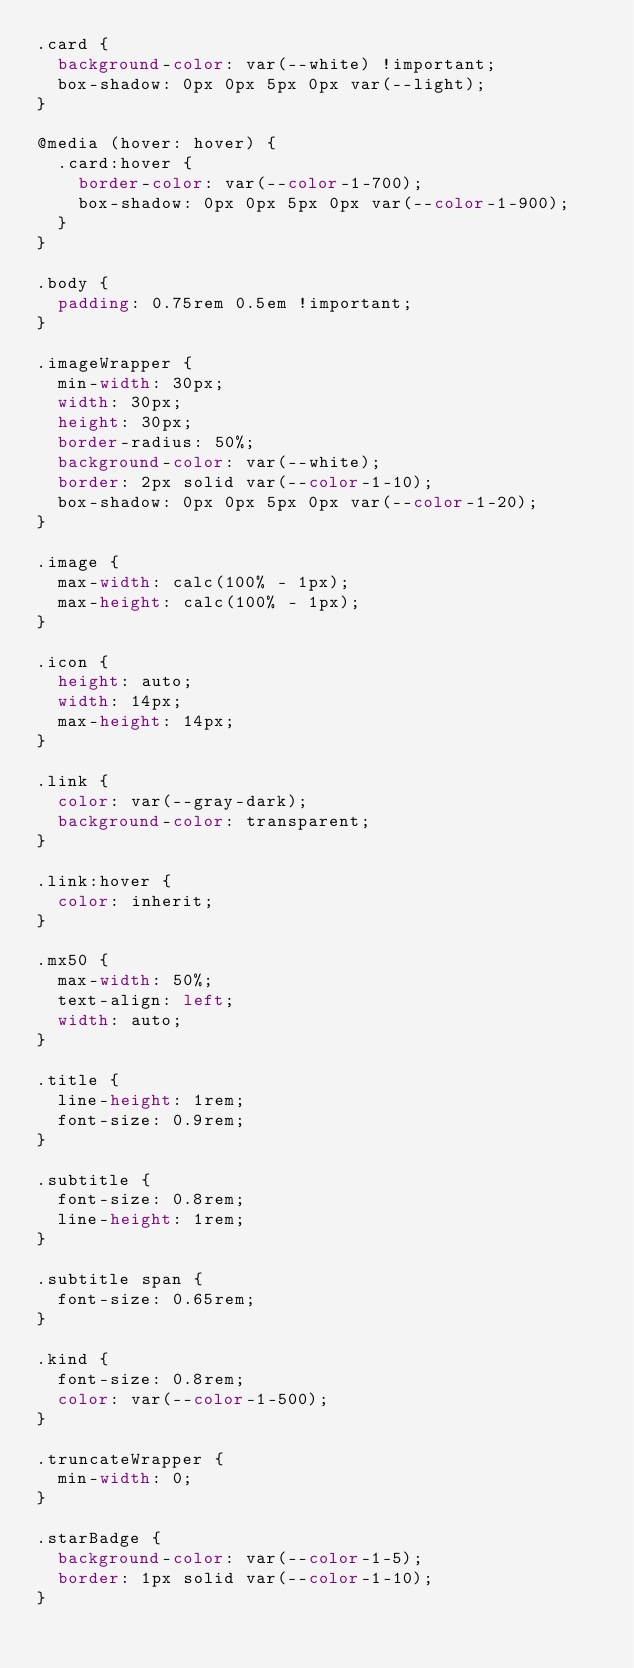Convert code to text. <code><loc_0><loc_0><loc_500><loc_500><_CSS_>.card {
  background-color: var(--white) !important;
  box-shadow: 0px 0px 5px 0px var(--light);
}

@media (hover: hover) {
  .card:hover {
    border-color: var(--color-1-700);
    box-shadow: 0px 0px 5px 0px var(--color-1-900);
  }
}

.body {
  padding: 0.75rem 0.5em !important;
}

.imageWrapper {
  min-width: 30px;
  width: 30px;
  height: 30px;
  border-radius: 50%;
  background-color: var(--white);
  border: 2px solid var(--color-1-10);
  box-shadow: 0px 0px 5px 0px var(--color-1-20);
}

.image {
  max-width: calc(100% - 1px);
  max-height: calc(100% - 1px);
}

.icon {
  height: auto;
  width: 14px;
  max-height: 14px;
}

.link {
  color: var(--gray-dark);
  background-color: transparent;
}

.link:hover {
  color: inherit;
}

.mx50 {
  max-width: 50%;
  text-align: left;
  width: auto;
}

.title {
  line-height: 1rem;
  font-size: 0.9rem;
}

.subtitle {
  font-size: 0.8rem;
  line-height: 1rem;
}

.subtitle span {
  font-size: 0.65rem;
}

.kind {
  font-size: 0.8rem;
  color: var(--color-1-500);
}

.truncateWrapper {
  min-width: 0;
}

.starBadge {
  background-color: var(--color-1-5);
  border: 1px solid var(--color-1-10);
}
</code> 